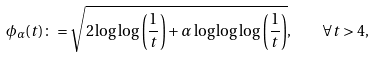Convert formula to latex. <formula><loc_0><loc_0><loc_500><loc_500>\phi _ { \alpha } ( t ) \colon = \sqrt { 2 \log \log \left ( \frac { 1 } { t } \right ) + \alpha \log \log \log \left ( \frac { 1 } { t } \right ) } , \quad \forall t > 4 ,</formula> 